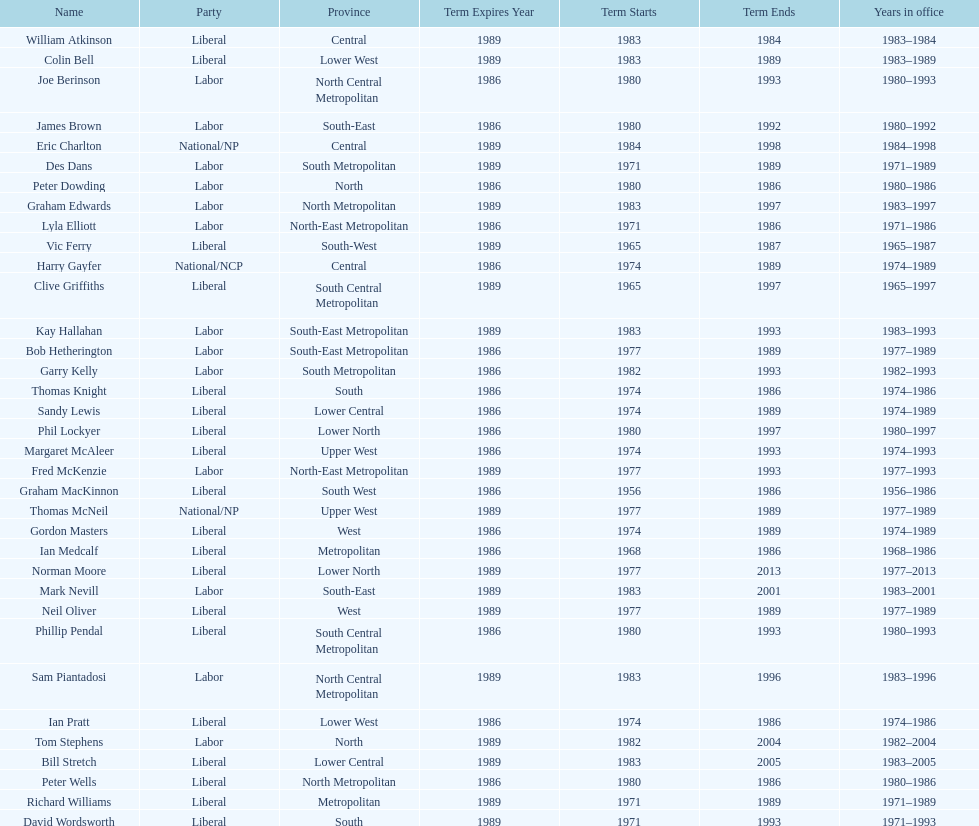How many members were party of lower west province? 2. 